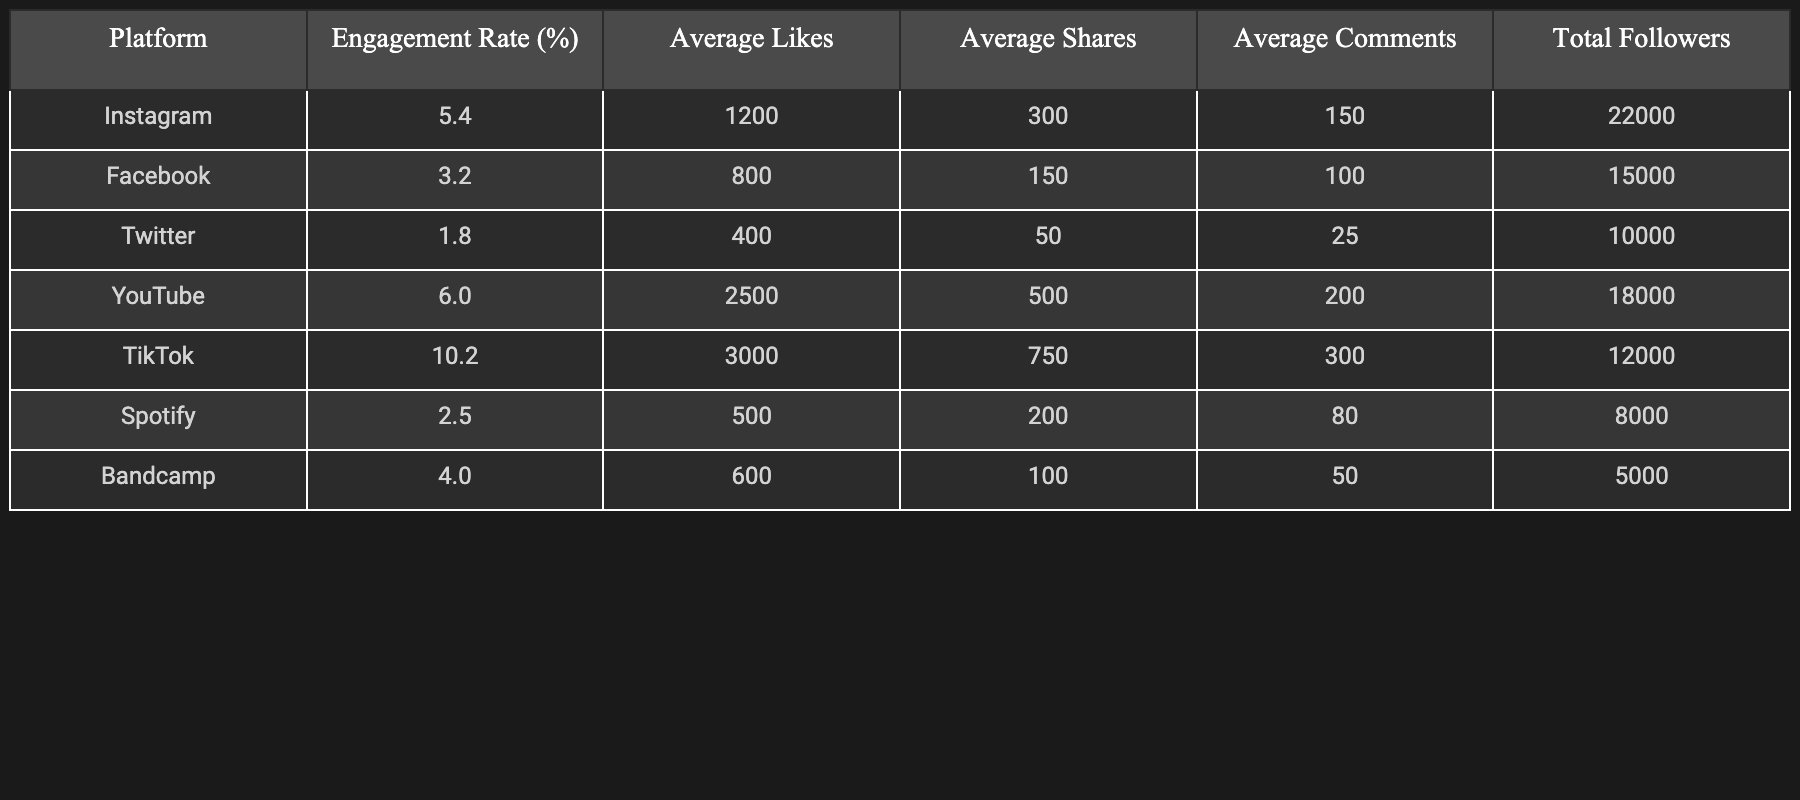What is the engagement rate for TikTok? You can find the engagement rate by looking at the row for TikTok in the table. The engagement rate is given as **10.2%**.
Answer: 10.2% Which platform has the highest average likes? The average likes are compared across the platforms, and the highest value is for YouTube with **2500** likes.
Answer: 2500 What is the average engagement rate of all platforms combined? To find the average engagement rate, add up the engagement rates: \(5.4 + 3.2 + 1.8 + 6.0 + 10.2 + 2.5 + 4.0 = 33.1\). There are 7 platforms, so divide to find the average: \(33.1 / 7 \approx 4.73\% \).
Answer: 4.73% Does Instagram have a higher engagement rate than Facebook? By comparing the engagement rates, Instagram is at **5.4%** and Facebook at **3.2%**, so Instagram does indeed have a higher engagement rate.
Answer: Yes Which platform has the lowest total followers? Looking through the total followers, the platform with the lowest count is Bandcamp at **5000** followers.
Answer: 5000 If we consider the average comments across all platforms, what is the median value? To find the median, list the average comments in order: **25, 50, 80, 100, 150, 200, 300**. The median value from this ordered list is the fourth number: **100**.
Answer: 100 Which platform has the greatest disparity between average likes and average shares? Calculate the disparity for each platform by subtracting average shares from average likes. The disparities are: Instagram \(1200 - 300 = 900\), Facebook \(800 - 150 = 650\), Twitter \(400 - 50 = 350\), YouTube \(2500 - 500 = 2000\), TikTok \(3000 - 750 = 2250\), Spotify \(500 - 200 = 300\), Bandcamp \(600 - 100 = 500\). The greatest disparity is with TikTok at **2250 likes**.
Answer: 2250 Is the average number of shares on YouTube greater than the average number of comments on Instagram? The average shares on YouTube are noted as **500**, while Instagram has average comments of **150**. Since **500** is greater than **150**, the statement is true.
Answer: Yes Which platform has the highest engagement rate and what is its average comments? The platform with the highest engagement rate is TikTok with **10.2%** engagement. The average comments for TikTok is **300**.
Answer: 10.2% and 300 If we sum the total followers of all platforms, what is the total? The total followers are calculated by adding: \(22000 + 15000 + 10000 + 18000 + 12000 + 8000 + 5000 = 100000\).
Answer: 100000 